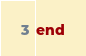Convert code to text. <code><loc_0><loc_0><loc_500><loc_500><_Crystal_>
end
</code> 